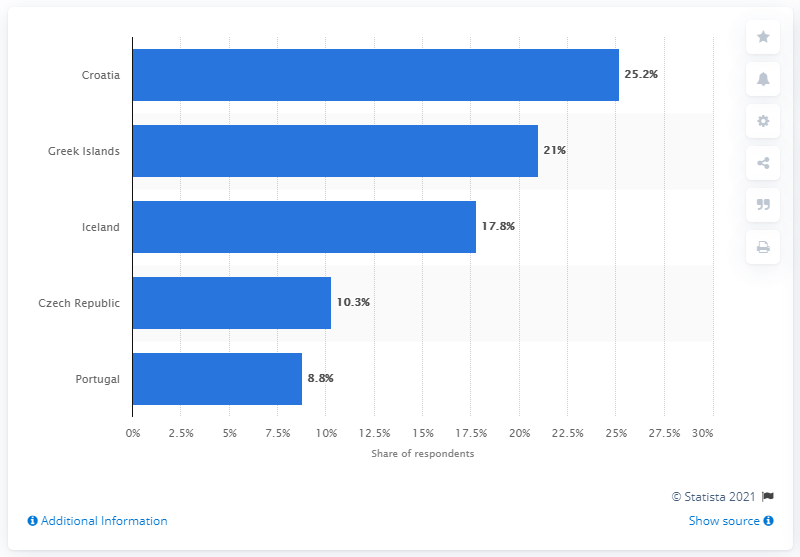Draw attention to some important aspects in this diagram. Croatia was considered the most up-and-coming travel destination in Europe for 2015. Iceland has the median value among all countries. The sum of two highest values is 46.2. 